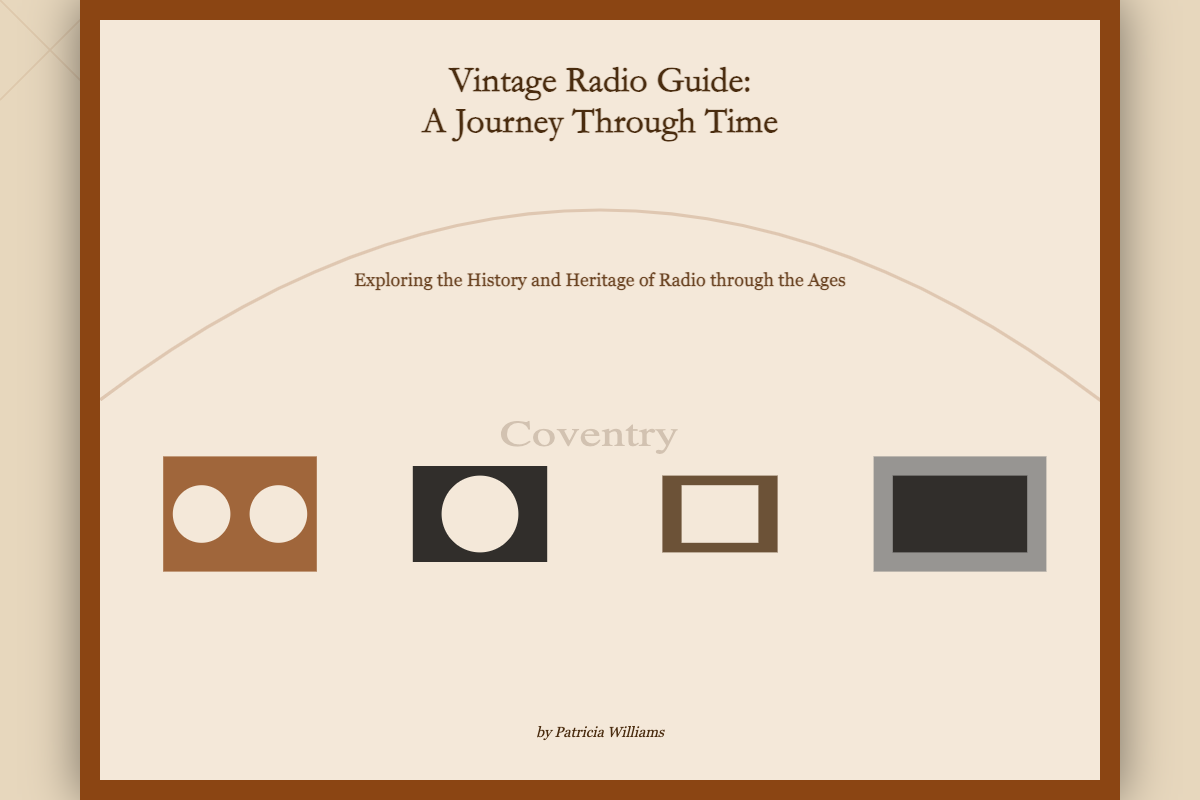What is the title of the book? The title of the book is prominently displayed at the top of the cover, stating "Vintage Radio Guide: A Journey Through Time".
Answer: Vintage Radio Guide: A Journey Through Time Who is the author of the book? The author's name is found at the bottom of the cover, indicating who wrote the book.
Answer: Patricia Williams What is the subtitle of the book? The subtitle provides additional context about the content of the book, appearing just below the title.
Answer: Exploring the History and Heritage of Radio through the Ages How many radio illustrations are shown on the cover? The number of radio illustrations can be counted in the designated section of the cover where they are displayed.
Answer: Four What is the background of the book cover? The background uniquely combines local heritage, which is represented through the map.
Answer: Coventry Map Which decade does the first radio illustration represent? Each radio illustration corresponds to a specific decade, identifiable in the sequence they are displayed.
Answer: 1920s What color is the border of the cover content? The border color can be identified as part of the design elements framing the cover content.
Answer: Brown In what style is the title text displayed? The style of the text can be identified based on the font used for the title.
Answer: Classic serif font 